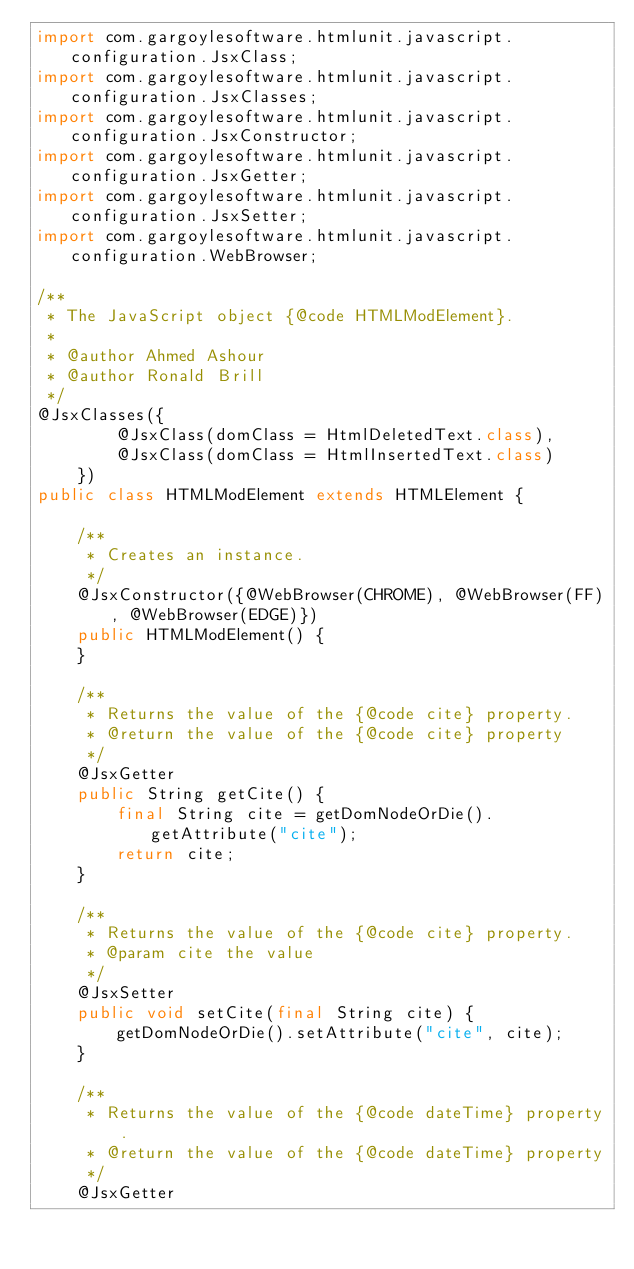<code> <loc_0><loc_0><loc_500><loc_500><_Java_>import com.gargoylesoftware.htmlunit.javascript.configuration.JsxClass;
import com.gargoylesoftware.htmlunit.javascript.configuration.JsxClasses;
import com.gargoylesoftware.htmlunit.javascript.configuration.JsxConstructor;
import com.gargoylesoftware.htmlunit.javascript.configuration.JsxGetter;
import com.gargoylesoftware.htmlunit.javascript.configuration.JsxSetter;
import com.gargoylesoftware.htmlunit.javascript.configuration.WebBrowser;

/**
 * The JavaScript object {@code HTMLModElement}.
 *
 * @author Ahmed Ashour
 * @author Ronald Brill
 */
@JsxClasses({
        @JsxClass(domClass = HtmlDeletedText.class),
        @JsxClass(domClass = HtmlInsertedText.class)
    })
public class HTMLModElement extends HTMLElement {

    /**
     * Creates an instance.
     */
    @JsxConstructor({@WebBrowser(CHROME), @WebBrowser(FF), @WebBrowser(EDGE)})
    public HTMLModElement() {
    }

    /**
     * Returns the value of the {@code cite} property.
     * @return the value of the {@code cite} property
     */
    @JsxGetter
    public String getCite() {
        final String cite = getDomNodeOrDie().getAttribute("cite");
        return cite;
    }

    /**
     * Returns the value of the {@code cite} property.
     * @param cite the value
     */
    @JsxSetter
    public void setCite(final String cite) {
        getDomNodeOrDie().setAttribute("cite", cite);
    }

    /**
     * Returns the value of the {@code dateTime} property.
     * @return the value of the {@code dateTime} property
     */
    @JsxGetter</code> 